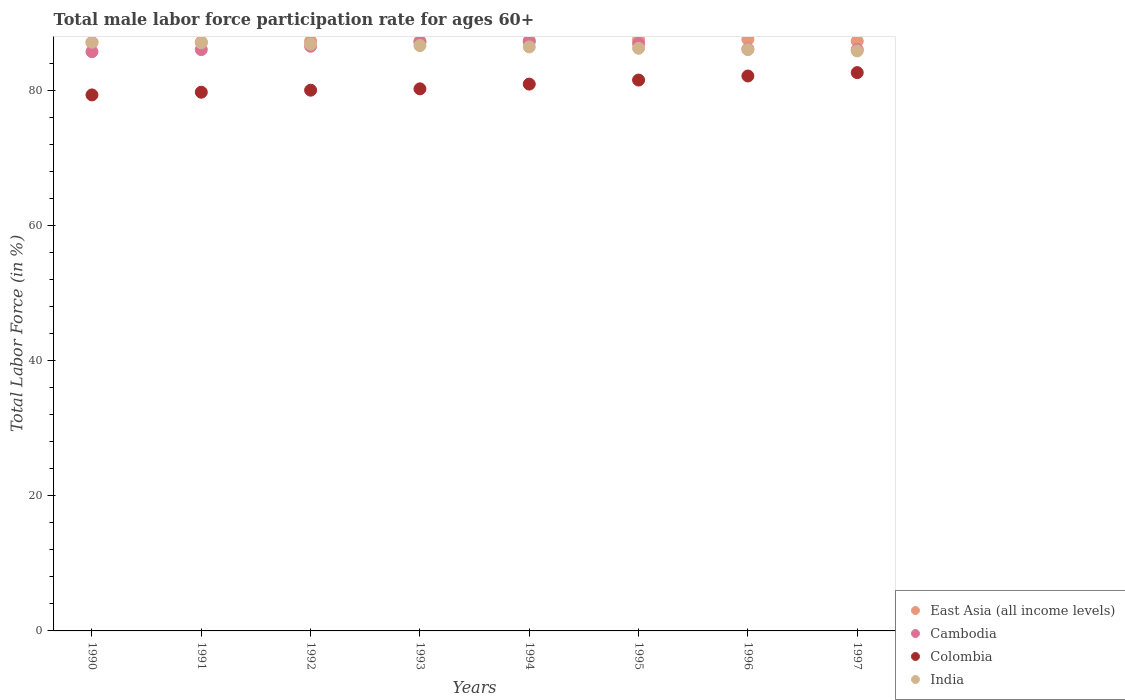How many different coloured dotlines are there?
Keep it short and to the point. 4. Is the number of dotlines equal to the number of legend labels?
Offer a very short reply. Yes. What is the male labor force participation rate in India in 1990?
Provide a short and direct response. 87.1. Across all years, what is the maximum male labor force participation rate in Cambodia?
Make the answer very short. 87.2. Across all years, what is the minimum male labor force participation rate in Cambodia?
Keep it short and to the point. 85.7. What is the total male labor force participation rate in Colombia in the graph?
Your answer should be compact. 646.3. What is the difference between the male labor force participation rate in India in 1990 and that in 1997?
Ensure brevity in your answer.  1.3. What is the difference between the male labor force participation rate in Colombia in 1991 and the male labor force participation rate in Cambodia in 1995?
Offer a very short reply. -7.2. What is the average male labor force participation rate in India per year?
Provide a succinct answer. 86.49. In the year 1992, what is the difference between the male labor force participation rate in East Asia (all income levels) and male labor force participation rate in India?
Your answer should be compact. 0.44. What is the ratio of the male labor force participation rate in Colombia in 1992 to that in 1997?
Keep it short and to the point. 0.97. What is the difference between the highest and the second highest male labor force participation rate in Cambodia?
Offer a terse response. 0.1. What is the difference between the highest and the lowest male labor force participation rate in East Asia (all income levels)?
Your response must be concise. 0.46. Is it the case that in every year, the sum of the male labor force participation rate in India and male labor force participation rate in East Asia (all income levels)  is greater than the sum of male labor force participation rate in Colombia and male labor force participation rate in Cambodia?
Keep it short and to the point. No. Is the male labor force participation rate in East Asia (all income levels) strictly greater than the male labor force participation rate in India over the years?
Your answer should be compact. No. What is the difference between two consecutive major ticks on the Y-axis?
Make the answer very short. 20. Are the values on the major ticks of Y-axis written in scientific E-notation?
Offer a very short reply. No. Does the graph contain any zero values?
Offer a terse response. No. Where does the legend appear in the graph?
Your response must be concise. Bottom right. How many legend labels are there?
Offer a very short reply. 4. What is the title of the graph?
Your answer should be very brief. Total male labor force participation rate for ages 60+. What is the label or title of the X-axis?
Give a very brief answer. Years. What is the Total Labor Force (in %) of East Asia (all income levels) in 1990?
Your answer should be compact. 87.06. What is the Total Labor Force (in %) in Cambodia in 1990?
Provide a short and direct response. 85.7. What is the Total Labor Force (in %) of Colombia in 1990?
Your answer should be very brief. 79.3. What is the Total Labor Force (in %) of India in 1990?
Your answer should be compact. 87.1. What is the Total Labor Force (in %) of East Asia (all income levels) in 1991?
Keep it short and to the point. 87.12. What is the Total Labor Force (in %) in Colombia in 1991?
Your answer should be compact. 79.7. What is the Total Labor Force (in %) of India in 1991?
Provide a succinct answer. 87. What is the Total Labor Force (in %) in East Asia (all income levels) in 1992?
Provide a succinct answer. 87.24. What is the Total Labor Force (in %) in Cambodia in 1992?
Your answer should be compact. 86.5. What is the Total Labor Force (in %) in India in 1992?
Offer a very short reply. 86.8. What is the Total Labor Force (in %) of East Asia (all income levels) in 1993?
Provide a succinct answer. 87.27. What is the Total Labor Force (in %) of Cambodia in 1993?
Your answer should be very brief. 87.1. What is the Total Labor Force (in %) of Colombia in 1993?
Your answer should be compact. 80.2. What is the Total Labor Force (in %) in India in 1993?
Offer a terse response. 86.6. What is the Total Labor Force (in %) in East Asia (all income levels) in 1994?
Provide a succinct answer. 87.32. What is the Total Labor Force (in %) of Cambodia in 1994?
Your response must be concise. 87.2. What is the Total Labor Force (in %) of Colombia in 1994?
Ensure brevity in your answer.  80.9. What is the Total Labor Force (in %) of India in 1994?
Keep it short and to the point. 86.4. What is the Total Labor Force (in %) in East Asia (all income levels) in 1995?
Your response must be concise. 87.46. What is the Total Labor Force (in %) of Cambodia in 1995?
Keep it short and to the point. 86.9. What is the Total Labor Force (in %) of Colombia in 1995?
Offer a very short reply. 81.5. What is the Total Labor Force (in %) in India in 1995?
Your answer should be compact. 86.2. What is the Total Labor Force (in %) of East Asia (all income levels) in 1996?
Offer a terse response. 87.52. What is the Total Labor Force (in %) of Cambodia in 1996?
Your answer should be very brief. 86.1. What is the Total Labor Force (in %) in Colombia in 1996?
Offer a terse response. 82.1. What is the Total Labor Force (in %) in East Asia (all income levels) in 1997?
Your response must be concise. 87.25. What is the Total Labor Force (in %) of Cambodia in 1997?
Your answer should be compact. 86. What is the Total Labor Force (in %) of Colombia in 1997?
Keep it short and to the point. 82.6. What is the Total Labor Force (in %) in India in 1997?
Provide a short and direct response. 85.8. Across all years, what is the maximum Total Labor Force (in %) in East Asia (all income levels)?
Provide a short and direct response. 87.52. Across all years, what is the maximum Total Labor Force (in %) of Cambodia?
Offer a terse response. 87.2. Across all years, what is the maximum Total Labor Force (in %) of Colombia?
Keep it short and to the point. 82.6. Across all years, what is the maximum Total Labor Force (in %) in India?
Keep it short and to the point. 87.1. Across all years, what is the minimum Total Labor Force (in %) in East Asia (all income levels)?
Ensure brevity in your answer.  87.06. Across all years, what is the minimum Total Labor Force (in %) of Cambodia?
Keep it short and to the point. 85.7. Across all years, what is the minimum Total Labor Force (in %) in Colombia?
Ensure brevity in your answer.  79.3. Across all years, what is the minimum Total Labor Force (in %) of India?
Your answer should be compact. 85.8. What is the total Total Labor Force (in %) of East Asia (all income levels) in the graph?
Keep it short and to the point. 698.25. What is the total Total Labor Force (in %) in Cambodia in the graph?
Provide a short and direct response. 691.5. What is the total Total Labor Force (in %) of Colombia in the graph?
Provide a succinct answer. 646.3. What is the total Total Labor Force (in %) in India in the graph?
Make the answer very short. 691.9. What is the difference between the Total Labor Force (in %) of East Asia (all income levels) in 1990 and that in 1991?
Offer a very short reply. -0.06. What is the difference between the Total Labor Force (in %) of Cambodia in 1990 and that in 1991?
Your response must be concise. -0.3. What is the difference between the Total Labor Force (in %) of India in 1990 and that in 1991?
Keep it short and to the point. 0.1. What is the difference between the Total Labor Force (in %) of East Asia (all income levels) in 1990 and that in 1992?
Your response must be concise. -0.18. What is the difference between the Total Labor Force (in %) in Cambodia in 1990 and that in 1992?
Your response must be concise. -0.8. What is the difference between the Total Labor Force (in %) in East Asia (all income levels) in 1990 and that in 1993?
Your answer should be compact. -0.21. What is the difference between the Total Labor Force (in %) in Cambodia in 1990 and that in 1993?
Give a very brief answer. -1.4. What is the difference between the Total Labor Force (in %) of East Asia (all income levels) in 1990 and that in 1994?
Provide a succinct answer. -0.26. What is the difference between the Total Labor Force (in %) in Cambodia in 1990 and that in 1994?
Your answer should be compact. -1.5. What is the difference between the Total Labor Force (in %) in India in 1990 and that in 1994?
Offer a very short reply. 0.7. What is the difference between the Total Labor Force (in %) in East Asia (all income levels) in 1990 and that in 1995?
Ensure brevity in your answer.  -0.39. What is the difference between the Total Labor Force (in %) in Cambodia in 1990 and that in 1995?
Provide a short and direct response. -1.2. What is the difference between the Total Labor Force (in %) of East Asia (all income levels) in 1990 and that in 1996?
Your response must be concise. -0.46. What is the difference between the Total Labor Force (in %) of Cambodia in 1990 and that in 1996?
Offer a terse response. -0.4. What is the difference between the Total Labor Force (in %) of Colombia in 1990 and that in 1996?
Make the answer very short. -2.8. What is the difference between the Total Labor Force (in %) of East Asia (all income levels) in 1990 and that in 1997?
Provide a succinct answer. -0.19. What is the difference between the Total Labor Force (in %) of Cambodia in 1990 and that in 1997?
Make the answer very short. -0.3. What is the difference between the Total Labor Force (in %) in Colombia in 1990 and that in 1997?
Give a very brief answer. -3.3. What is the difference between the Total Labor Force (in %) in India in 1990 and that in 1997?
Provide a succinct answer. 1.3. What is the difference between the Total Labor Force (in %) of East Asia (all income levels) in 1991 and that in 1992?
Your answer should be compact. -0.12. What is the difference between the Total Labor Force (in %) of Cambodia in 1991 and that in 1992?
Offer a terse response. -0.5. What is the difference between the Total Labor Force (in %) in Colombia in 1991 and that in 1992?
Your response must be concise. -0.3. What is the difference between the Total Labor Force (in %) in East Asia (all income levels) in 1991 and that in 1993?
Provide a short and direct response. -0.15. What is the difference between the Total Labor Force (in %) of Cambodia in 1991 and that in 1993?
Your answer should be compact. -1.1. What is the difference between the Total Labor Force (in %) in India in 1991 and that in 1993?
Your response must be concise. 0.4. What is the difference between the Total Labor Force (in %) of East Asia (all income levels) in 1991 and that in 1994?
Ensure brevity in your answer.  -0.2. What is the difference between the Total Labor Force (in %) in Cambodia in 1991 and that in 1994?
Offer a terse response. -1.2. What is the difference between the Total Labor Force (in %) of Colombia in 1991 and that in 1994?
Your answer should be very brief. -1.2. What is the difference between the Total Labor Force (in %) of India in 1991 and that in 1994?
Make the answer very short. 0.6. What is the difference between the Total Labor Force (in %) in East Asia (all income levels) in 1991 and that in 1995?
Keep it short and to the point. -0.33. What is the difference between the Total Labor Force (in %) of Cambodia in 1991 and that in 1995?
Ensure brevity in your answer.  -0.9. What is the difference between the Total Labor Force (in %) of India in 1991 and that in 1995?
Offer a terse response. 0.8. What is the difference between the Total Labor Force (in %) of East Asia (all income levels) in 1991 and that in 1996?
Provide a succinct answer. -0.4. What is the difference between the Total Labor Force (in %) in Colombia in 1991 and that in 1996?
Provide a short and direct response. -2.4. What is the difference between the Total Labor Force (in %) in East Asia (all income levels) in 1991 and that in 1997?
Ensure brevity in your answer.  -0.13. What is the difference between the Total Labor Force (in %) in East Asia (all income levels) in 1992 and that in 1993?
Your response must be concise. -0.03. What is the difference between the Total Labor Force (in %) in Colombia in 1992 and that in 1993?
Offer a very short reply. -0.2. What is the difference between the Total Labor Force (in %) of East Asia (all income levels) in 1992 and that in 1994?
Make the answer very short. -0.08. What is the difference between the Total Labor Force (in %) of Colombia in 1992 and that in 1994?
Your answer should be very brief. -0.9. What is the difference between the Total Labor Force (in %) in India in 1992 and that in 1994?
Your answer should be compact. 0.4. What is the difference between the Total Labor Force (in %) of East Asia (all income levels) in 1992 and that in 1995?
Your answer should be very brief. -0.21. What is the difference between the Total Labor Force (in %) of Cambodia in 1992 and that in 1995?
Your response must be concise. -0.4. What is the difference between the Total Labor Force (in %) of Colombia in 1992 and that in 1995?
Your answer should be compact. -1.5. What is the difference between the Total Labor Force (in %) of India in 1992 and that in 1995?
Make the answer very short. 0.6. What is the difference between the Total Labor Force (in %) of East Asia (all income levels) in 1992 and that in 1996?
Provide a succinct answer. -0.28. What is the difference between the Total Labor Force (in %) in Cambodia in 1992 and that in 1996?
Your response must be concise. 0.4. What is the difference between the Total Labor Force (in %) of Colombia in 1992 and that in 1996?
Your answer should be compact. -2.1. What is the difference between the Total Labor Force (in %) of East Asia (all income levels) in 1992 and that in 1997?
Your answer should be compact. -0.01. What is the difference between the Total Labor Force (in %) of Colombia in 1992 and that in 1997?
Provide a short and direct response. -2.6. What is the difference between the Total Labor Force (in %) of East Asia (all income levels) in 1993 and that in 1994?
Your answer should be compact. -0.05. What is the difference between the Total Labor Force (in %) in Cambodia in 1993 and that in 1994?
Keep it short and to the point. -0.1. What is the difference between the Total Labor Force (in %) of India in 1993 and that in 1994?
Provide a succinct answer. 0.2. What is the difference between the Total Labor Force (in %) in East Asia (all income levels) in 1993 and that in 1995?
Offer a terse response. -0.18. What is the difference between the Total Labor Force (in %) in Cambodia in 1993 and that in 1995?
Offer a terse response. 0.2. What is the difference between the Total Labor Force (in %) of Colombia in 1993 and that in 1995?
Your response must be concise. -1.3. What is the difference between the Total Labor Force (in %) of East Asia (all income levels) in 1993 and that in 1996?
Offer a terse response. -0.25. What is the difference between the Total Labor Force (in %) of Cambodia in 1993 and that in 1996?
Keep it short and to the point. 1. What is the difference between the Total Labor Force (in %) of Colombia in 1993 and that in 1996?
Offer a terse response. -1.9. What is the difference between the Total Labor Force (in %) of India in 1993 and that in 1996?
Make the answer very short. 0.6. What is the difference between the Total Labor Force (in %) in East Asia (all income levels) in 1993 and that in 1997?
Your answer should be very brief. 0.02. What is the difference between the Total Labor Force (in %) in Cambodia in 1993 and that in 1997?
Your response must be concise. 1.1. What is the difference between the Total Labor Force (in %) in Colombia in 1993 and that in 1997?
Provide a short and direct response. -2.4. What is the difference between the Total Labor Force (in %) of India in 1993 and that in 1997?
Your answer should be very brief. 0.8. What is the difference between the Total Labor Force (in %) of East Asia (all income levels) in 1994 and that in 1995?
Ensure brevity in your answer.  -0.13. What is the difference between the Total Labor Force (in %) in Cambodia in 1994 and that in 1995?
Keep it short and to the point. 0.3. What is the difference between the Total Labor Force (in %) in East Asia (all income levels) in 1994 and that in 1996?
Keep it short and to the point. -0.2. What is the difference between the Total Labor Force (in %) of Cambodia in 1994 and that in 1996?
Ensure brevity in your answer.  1.1. What is the difference between the Total Labor Force (in %) of East Asia (all income levels) in 1994 and that in 1997?
Offer a terse response. 0.07. What is the difference between the Total Labor Force (in %) of East Asia (all income levels) in 1995 and that in 1996?
Your answer should be compact. -0.07. What is the difference between the Total Labor Force (in %) of India in 1995 and that in 1996?
Keep it short and to the point. 0.2. What is the difference between the Total Labor Force (in %) in East Asia (all income levels) in 1995 and that in 1997?
Your answer should be compact. 0.2. What is the difference between the Total Labor Force (in %) in Cambodia in 1995 and that in 1997?
Provide a short and direct response. 0.9. What is the difference between the Total Labor Force (in %) in India in 1995 and that in 1997?
Offer a very short reply. 0.4. What is the difference between the Total Labor Force (in %) of East Asia (all income levels) in 1996 and that in 1997?
Keep it short and to the point. 0.27. What is the difference between the Total Labor Force (in %) in Cambodia in 1996 and that in 1997?
Provide a succinct answer. 0.1. What is the difference between the Total Labor Force (in %) in Colombia in 1996 and that in 1997?
Offer a terse response. -0.5. What is the difference between the Total Labor Force (in %) of India in 1996 and that in 1997?
Your answer should be very brief. 0.2. What is the difference between the Total Labor Force (in %) in East Asia (all income levels) in 1990 and the Total Labor Force (in %) in Cambodia in 1991?
Give a very brief answer. 1.06. What is the difference between the Total Labor Force (in %) in East Asia (all income levels) in 1990 and the Total Labor Force (in %) in Colombia in 1991?
Your response must be concise. 7.36. What is the difference between the Total Labor Force (in %) of East Asia (all income levels) in 1990 and the Total Labor Force (in %) of India in 1991?
Ensure brevity in your answer.  0.06. What is the difference between the Total Labor Force (in %) of Cambodia in 1990 and the Total Labor Force (in %) of Colombia in 1991?
Your answer should be very brief. 6. What is the difference between the Total Labor Force (in %) in Colombia in 1990 and the Total Labor Force (in %) in India in 1991?
Your response must be concise. -7.7. What is the difference between the Total Labor Force (in %) in East Asia (all income levels) in 1990 and the Total Labor Force (in %) in Cambodia in 1992?
Provide a short and direct response. 0.56. What is the difference between the Total Labor Force (in %) in East Asia (all income levels) in 1990 and the Total Labor Force (in %) in Colombia in 1992?
Ensure brevity in your answer.  7.06. What is the difference between the Total Labor Force (in %) of East Asia (all income levels) in 1990 and the Total Labor Force (in %) of India in 1992?
Your answer should be compact. 0.26. What is the difference between the Total Labor Force (in %) in Cambodia in 1990 and the Total Labor Force (in %) in Colombia in 1992?
Provide a succinct answer. 5.7. What is the difference between the Total Labor Force (in %) in Colombia in 1990 and the Total Labor Force (in %) in India in 1992?
Ensure brevity in your answer.  -7.5. What is the difference between the Total Labor Force (in %) of East Asia (all income levels) in 1990 and the Total Labor Force (in %) of Cambodia in 1993?
Offer a terse response. -0.04. What is the difference between the Total Labor Force (in %) in East Asia (all income levels) in 1990 and the Total Labor Force (in %) in Colombia in 1993?
Ensure brevity in your answer.  6.86. What is the difference between the Total Labor Force (in %) in East Asia (all income levels) in 1990 and the Total Labor Force (in %) in India in 1993?
Your response must be concise. 0.46. What is the difference between the Total Labor Force (in %) of Cambodia in 1990 and the Total Labor Force (in %) of Colombia in 1993?
Provide a short and direct response. 5.5. What is the difference between the Total Labor Force (in %) in Colombia in 1990 and the Total Labor Force (in %) in India in 1993?
Provide a short and direct response. -7.3. What is the difference between the Total Labor Force (in %) in East Asia (all income levels) in 1990 and the Total Labor Force (in %) in Cambodia in 1994?
Keep it short and to the point. -0.14. What is the difference between the Total Labor Force (in %) of East Asia (all income levels) in 1990 and the Total Labor Force (in %) of Colombia in 1994?
Your response must be concise. 6.16. What is the difference between the Total Labor Force (in %) of East Asia (all income levels) in 1990 and the Total Labor Force (in %) of India in 1994?
Offer a terse response. 0.66. What is the difference between the Total Labor Force (in %) of Cambodia in 1990 and the Total Labor Force (in %) of Colombia in 1994?
Provide a succinct answer. 4.8. What is the difference between the Total Labor Force (in %) of Cambodia in 1990 and the Total Labor Force (in %) of India in 1994?
Offer a very short reply. -0.7. What is the difference between the Total Labor Force (in %) of East Asia (all income levels) in 1990 and the Total Labor Force (in %) of Cambodia in 1995?
Offer a terse response. 0.16. What is the difference between the Total Labor Force (in %) of East Asia (all income levels) in 1990 and the Total Labor Force (in %) of Colombia in 1995?
Provide a succinct answer. 5.56. What is the difference between the Total Labor Force (in %) of East Asia (all income levels) in 1990 and the Total Labor Force (in %) of India in 1995?
Offer a very short reply. 0.86. What is the difference between the Total Labor Force (in %) of Cambodia in 1990 and the Total Labor Force (in %) of Colombia in 1995?
Keep it short and to the point. 4.2. What is the difference between the Total Labor Force (in %) of Cambodia in 1990 and the Total Labor Force (in %) of India in 1995?
Offer a very short reply. -0.5. What is the difference between the Total Labor Force (in %) of East Asia (all income levels) in 1990 and the Total Labor Force (in %) of Cambodia in 1996?
Make the answer very short. 0.96. What is the difference between the Total Labor Force (in %) of East Asia (all income levels) in 1990 and the Total Labor Force (in %) of Colombia in 1996?
Offer a very short reply. 4.96. What is the difference between the Total Labor Force (in %) in East Asia (all income levels) in 1990 and the Total Labor Force (in %) in India in 1996?
Offer a terse response. 1.06. What is the difference between the Total Labor Force (in %) in East Asia (all income levels) in 1990 and the Total Labor Force (in %) in Cambodia in 1997?
Offer a very short reply. 1.06. What is the difference between the Total Labor Force (in %) of East Asia (all income levels) in 1990 and the Total Labor Force (in %) of Colombia in 1997?
Ensure brevity in your answer.  4.46. What is the difference between the Total Labor Force (in %) in East Asia (all income levels) in 1990 and the Total Labor Force (in %) in India in 1997?
Provide a short and direct response. 1.26. What is the difference between the Total Labor Force (in %) in Cambodia in 1990 and the Total Labor Force (in %) in India in 1997?
Your answer should be very brief. -0.1. What is the difference between the Total Labor Force (in %) in East Asia (all income levels) in 1991 and the Total Labor Force (in %) in Cambodia in 1992?
Keep it short and to the point. 0.62. What is the difference between the Total Labor Force (in %) of East Asia (all income levels) in 1991 and the Total Labor Force (in %) of Colombia in 1992?
Your response must be concise. 7.12. What is the difference between the Total Labor Force (in %) of East Asia (all income levels) in 1991 and the Total Labor Force (in %) of India in 1992?
Keep it short and to the point. 0.32. What is the difference between the Total Labor Force (in %) of Cambodia in 1991 and the Total Labor Force (in %) of India in 1992?
Your answer should be compact. -0.8. What is the difference between the Total Labor Force (in %) of Colombia in 1991 and the Total Labor Force (in %) of India in 1992?
Ensure brevity in your answer.  -7.1. What is the difference between the Total Labor Force (in %) in East Asia (all income levels) in 1991 and the Total Labor Force (in %) in Cambodia in 1993?
Your answer should be very brief. 0.02. What is the difference between the Total Labor Force (in %) in East Asia (all income levels) in 1991 and the Total Labor Force (in %) in Colombia in 1993?
Give a very brief answer. 6.92. What is the difference between the Total Labor Force (in %) in East Asia (all income levels) in 1991 and the Total Labor Force (in %) in India in 1993?
Give a very brief answer. 0.52. What is the difference between the Total Labor Force (in %) in Cambodia in 1991 and the Total Labor Force (in %) in India in 1993?
Offer a terse response. -0.6. What is the difference between the Total Labor Force (in %) of East Asia (all income levels) in 1991 and the Total Labor Force (in %) of Cambodia in 1994?
Your answer should be very brief. -0.08. What is the difference between the Total Labor Force (in %) of East Asia (all income levels) in 1991 and the Total Labor Force (in %) of Colombia in 1994?
Ensure brevity in your answer.  6.22. What is the difference between the Total Labor Force (in %) of East Asia (all income levels) in 1991 and the Total Labor Force (in %) of India in 1994?
Your answer should be compact. 0.72. What is the difference between the Total Labor Force (in %) of Cambodia in 1991 and the Total Labor Force (in %) of India in 1994?
Make the answer very short. -0.4. What is the difference between the Total Labor Force (in %) of East Asia (all income levels) in 1991 and the Total Labor Force (in %) of Cambodia in 1995?
Provide a succinct answer. 0.22. What is the difference between the Total Labor Force (in %) in East Asia (all income levels) in 1991 and the Total Labor Force (in %) in Colombia in 1995?
Your answer should be compact. 5.62. What is the difference between the Total Labor Force (in %) in East Asia (all income levels) in 1991 and the Total Labor Force (in %) in India in 1995?
Provide a succinct answer. 0.92. What is the difference between the Total Labor Force (in %) in Cambodia in 1991 and the Total Labor Force (in %) in Colombia in 1995?
Give a very brief answer. 4.5. What is the difference between the Total Labor Force (in %) in Colombia in 1991 and the Total Labor Force (in %) in India in 1995?
Provide a short and direct response. -6.5. What is the difference between the Total Labor Force (in %) of East Asia (all income levels) in 1991 and the Total Labor Force (in %) of Cambodia in 1996?
Provide a succinct answer. 1.02. What is the difference between the Total Labor Force (in %) of East Asia (all income levels) in 1991 and the Total Labor Force (in %) of Colombia in 1996?
Offer a very short reply. 5.02. What is the difference between the Total Labor Force (in %) of East Asia (all income levels) in 1991 and the Total Labor Force (in %) of India in 1996?
Provide a succinct answer. 1.12. What is the difference between the Total Labor Force (in %) of Cambodia in 1991 and the Total Labor Force (in %) of India in 1996?
Offer a terse response. 0. What is the difference between the Total Labor Force (in %) in East Asia (all income levels) in 1991 and the Total Labor Force (in %) in Cambodia in 1997?
Your answer should be very brief. 1.12. What is the difference between the Total Labor Force (in %) in East Asia (all income levels) in 1991 and the Total Labor Force (in %) in Colombia in 1997?
Give a very brief answer. 4.52. What is the difference between the Total Labor Force (in %) in East Asia (all income levels) in 1991 and the Total Labor Force (in %) in India in 1997?
Keep it short and to the point. 1.32. What is the difference between the Total Labor Force (in %) of East Asia (all income levels) in 1992 and the Total Labor Force (in %) of Cambodia in 1993?
Your response must be concise. 0.14. What is the difference between the Total Labor Force (in %) in East Asia (all income levels) in 1992 and the Total Labor Force (in %) in Colombia in 1993?
Provide a short and direct response. 7.04. What is the difference between the Total Labor Force (in %) in East Asia (all income levels) in 1992 and the Total Labor Force (in %) in India in 1993?
Keep it short and to the point. 0.64. What is the difference between the Total Labor Force (in %) of Cambodia in 1992 and the Total Labor Force (in %) of Colombia in 1993?
Keep it short and to the point. 6.3. What is the difference between the Total Labor Force (in %) in Cambodia in 1992 and the Total Labor Force (in %) in India in 1993?
Offer a terse response. -0.1. What is the difference between the Total Labor Force (in %) of East Asia (all income levels) in 1992 and the Total Labor Force (in %) of Cambodia in 1994?
Your answer should be very brief. 0.04. What is the difference between the Total Labor Force (in %) of East Asia (all income levels) in 1992 and the Total Labor Force (in %) of Colombia in 1994?
Give a very brief answer. 6.34. What is the difference between the Total Labor Force (in %) of East Asia (all income levels) in 1992 and the Total Labor Force (in %) of India in 1994?
Offer a very short reply. 0.84. What is the difference between the Total Labor Force (in %) of Cambodia in 1992 and the Total Labor Force (in %) of Colombia in 1994?
Offer a very short reply. 5.6. What is the difference between the Total Labor Force (in %) of Cambodia in 1992 and the Total Labor Force (in %) of India in 1994?
Give a very brief answer. 0.1. What is the difference between the Total Labor Force (in %) in Colombia in 1992 and the Total Labor Force (in %) in India in 1994?
Give a very brief answer. -6.4. What is the difference between the Total Labor Force (in %) of East Asia (all income levels) in 1992 and the Total Labor Force (in %) of Cambodia in 1995?
Provide a succinct answer. 0.34. What is the difference between the Total Labor Force (in %) of East Asia (all income levels) in 1992 and the Total Labor Force (in %) of Colombia in 1995?
Offer a terse response. 5.74. What is the difference between the Total Labor Force (in %) in East Asia (all income levels) in 1992 and the Total Labor Force (in %) in India in 1995?
Offer a very short reply. 1.04. What is the difference between the Total Labor Force (in %) of East Asia (all income levels) in 1992 and the Total Labor Force (in %) of Cambodia in 1996?
Ensure brevity in your answer.  1.14. What is the difference between the Total Labor Force (in %) in East Asia (all income levels) in 1992 and the Total Labor Force (in %) in Colombia in 1996?
Offer a terse response. 5.14. What is the difference between the Total Labor Force (in %) in East Asia (all income levels) in 1992 and the Total Labor Force (in %) in India in 1996?
Keep it short and to the point. 1.24. What is the difference between the Total Labor Force (in %) of Cambodia in 1992 and the Total Labor Force (in %) of Colombia in 1996?
Your response must be concise. 4.4. What is the difference between the Total Labor Force (in %) in Colombia in 1992 and the Total Labor Force (in %) in India in 1996?
Ensure brevity in your answer.  -6. What is the difference between the Total Labor Force (in %) of East Asia (all income levels) in 1992 and the Total Labor Force (in %) of Cambodia in 1997?
Offer a very short reply. 1.24. What is the difference between the Total Labor Force (in %) of East Asia (all income levels) in 1992 and the Total Labor Force (in %) of Colombia in 1997?
Provide a short and direct response. 4.64. What is the difference between the Total Labor Force (in %) of East Asia (all income levels) in 1992 and the Total Labor Force (in %) of India in 1997?
Keep it short and to the point. 1.44. What is the difference between the Total Labor Force (in %) of Cambodia in 1992 and the Total Labor Force (in %) of India in 1997?
Provide a short and direct response. 0.7. What is the difference between the Total Labor Force (in %) of East Asia (all income levels) in 1993 and the Total Labor Force (in %) of Cambodia in 1994?
Make the answer very short. 0.07. What is the difference between the Total Labor Force (in %) of East Asia (all income levels) in 1993 and the Total Labor Force (in %) of Colombia in 1994?
Your response must be concise. 6.37. What is the difference between the Total Labor Force (in %) of East Asia (all income levels) in 1993 and the Total Labor Force (in %) of India in 1994?
Offer a very short reply. 0.87. What is the difference between the Total Labor Force (in %) of Cambodia in 1993 and the Total Labor Force (in %) of India in 1994?
Offer a very short reply. 0.7. What is the difference between the Total Labor Force (in %) of Colombia in 1993 and the Total Labor Force (in %) of India in 1994?
Make the answer very short. -6.2. What is the difference between the Total Labor Force (in %) of East Asia (all income levels) in 1993 and the Total Labor Force (in %) of Cambodia in 1995?
Your answer should be very brief. 0.37. What is the difference between the Total Labor Force (in %) in East Asia (all income levels) in 1993 and the Total Labor Force (in %) in Colombia in 1995?
Your response must be concise. 5.77. What is the difference between the Total Labor Force (in %) of East Asia (all income levels) in 1993 and the Total Labor Force (in %) of India in 1995?
Offer a terse response. 1.07. What is the difference between the Total Labor Force (in %) of Cambodia in 1993 and the Total Labor Force (in %) of Colombia in 1995?
Your answer should be very brief. 5.6. What is the difference between the Total Labor Force (in %) of East Asia (all income levels) in 1993 and the Total Labor Force (in %) of Cambodia in 1996?
Ensure brevity in your answer.  1.17. What is the difference between the Total Labor Force (in %) of East Asia (all income levels) in 1993 and the Total Labor Force (in %) of Colombia in 1996?
Offer a terse response. 5.17. What is the difference between the Total Labor Force (in %) of East Asia (all income levels) in 1993 and the Total Labor Force (in %) of India in 1996?
Provide a succinct answer. 1.27. What is the difference between the Total Labor Force (in %) in Cambodia in 1993 and the Total Labor Force (in %) in Colombia in 1996?
Give a very brief answer. 5. What is the difference between the Total Labor Force (in %) of Cambodia in 1993 and the Total Labor Force (in %) of India in 1996?
Your response must be concise. 1.1. What is the difference between the Total Labor Force (in %) in East Asia (all income levels) in 1993 and the Total Labor Force (in %) in Cambodia in 1997?
Your answer should be compact. 1.27. What is the difference between the Total Labor Force (in %) in East Asia (all income levels) in 1993 and the Total Labor Force (in %) in Colombia in 1997?
Your response must be concise. 4.67. What is the difference between the Total Labor Force (in %) in East Asia (all income levels) in 1993 and the Total Labor Force (in %) in India in 1997?
Offer a very short reply. 1.47. What is the difference between the Total Labor Force (in %) of Cambodia in 1993 and the Total Labor Force (in %) of India in 1997?
Your answer should be very brief. 1.3. What is the difference between the Total Labor Force (in %) of Colombia in 1993 and the Total Labor Force (in %) of India in 1997?
Provide a short and direct response. -5.6. What is the difference between the Total Labor Force (in %) in East Asia (all income levels) in 1994 and the Total Labor Force (in %) in Cambodia in 1995?
Ensure brevity in your answer.  0.42. What is the difference between the Total Labor Force (in %) of East Asia (all income levels) in 1994 and the Total Labor Force (in %) of Colombia in 1995?
Your response must be concise. 5.82. What is the difference between the Total Labor Force (in %) in East Asia (all income levels) in 1994 and the Total Labor Force (in %) in India in 1995?
Keep it short and to the point. 1.12. What is the difference between the Total Labor Force (in %) in Cambodia in 1994 and the Total Labor Force (in %) in Colombia in 1995?
Make the answer very short. 5.7. What is the difference between the Total Labor Force (in %) in East Asia (all income levels) in 1994 and the Total Labor Force (in %) in Cambodia in 1996?
Ensure brevity in your answer.  1.22. What is the difference between the Total Labor Force (in %) in East Asia (all income levels) in 1994 and the Total Labor Force (in %) in Colombia in 1996?
Offer a very short reply. 5.22. What is the difference between the Total Labor Force (in %) of East Asia (all income levels) in 1994 and the Total Labor Force (in %) of India in 1996?
Make the answer very short. 1.32. What is the difference between the Total Labor Force (in %) of Cambodia in 1994 and the Total Labor Force (in %) of Colombia in 1996?
Provide a succinct answer. 5.1. What is the difference between the Total Labor Force (in %) of Cambodia in 1994 and the Total Labor Force (in %) of India in 1996?
Offer a terse response. 1.2. What is the difference between the Total Labor Force (in %) in East Asia (all income levels) in 1994 and the Total Labor Force (in %) in Cambodia in 1997?
Give a very brief answer. 1.32. What is the difference between the Total Labor Force (in %) in East Asia (all income levels) in 1994 and the Total Labor Force (in %) in Colombia in 1997?
Make the answer very short. 4.72. What is the difference between the Total Labor Force (in %) of East Asia (all income levels) in 1994 and the Total Labor Force (in %) of India in 1997?
Make the answer very short. 1.52. What is the difference between the Total Labor Force (in %) of Cambodia in 1994 and the Total Labor Force (in %) of India in 1997?
Keep it short and to the point. 1.4. What is the difference between the Total Labor Force (in %) in East Asia (all income levels) in 1995 and the Total Labor Force (in %) in Cambodia in 1996?
Offer a terse response. 1.36. What is the difference between the Total Labor Force (in %) of East Asia (all income levels) in 1995 and the Total Labor Force (in %) of Colombia in 1996?
Provide a short and direct response. 5.36. What is the difference between the Total Labor Force (in %) in East Asia (all income levels) in 1995 and the Total Labor Force (in %) in India in 1996?
Keep it short and to the point. 1.46. What is the difference between the Total Labor Force (in %) in Cambodia in 1995 and the Total Labor Force (in %) in India in 1996?
Your answer should be compact. 0.9. What is the difference between the Total Labor Force (in %) of Colombia in 1995 and the Total Labor Force (in %) of India in 1996?
Your answer should be very brief. -4.5. What is the difference between the Total Labor Force (in %) in East Asia (all income levels) in 1995 and the Total Labor Force (in %) in Cambodia in 1997?
Your answer should be compact. 1.46. What is the difference between the Total Labor Force (in %) of East Asia (all income levels) in 1995 and the Total Labor Force (in %) of Colombia in 1997?
Ensure brevity in your answer.  4.86. What is the difference between the Total Labor Force (in %) of East Asia (all income levels) in 1995 and the Total Labor Force (in %) of India in 1997?
Your answer should be very brief. 1.66. What is the difference between the Total Labor Force (in %) in Cambodia in 1995 and the Total Labor Force (in %) in Colombia in 1997?
Provide a short and direct response. 4.3. What is the difference between the Total Labor Force (in %) of Cambodia in 1995 and the Total Labor Force (in %) of India in 1997?
Your answer should be very brief. 1.1. What is the difference between the Total Labor Force (in %) of East Asia (all income levels) in 1996 and the Total Labor Force (in %) of Cambodia in 1997?
Provide a succinct answer. 1.52. What is the difference between the Total Labor Force (in %) in East Asia (all income levels) in 1996 and the Total Labor Force (in %) in Colombia in 1997?
Make the answer very short. 4.92. What is the difference between the Total Labor Force (in %) in East Asia (all income levels) in 1996 and the Total Labor Force (in %) in India in 1997?
Provide a succinct answer. 1.72. What is the difference between the Total Labor Force (in %) of Cambodia in 1996 and the Total Labor Force (in %) of Colombia in 1997?
Offer a terse response. 3.5. What is the average Total Labor Force (in %) of East Asia (all income levels) per year?
Ensure brevity in your answer.  87.28. What is the average Total Labor Force (in %) in Cambodia per year?
Your response must be concise. 86.44. What is the average Total Labor Force (in %) in Colombia per year?
Provide a succinct answer. 80.79. What is the average Total Labor Force (in %) of India per year?
Give a very brief answer. 86.49. In the year 1990, what is the difference between the Total Labor Force (in %) of East Asia (all income levels) and Total Labor Force (in %) of Cambodia?
Provide a succinct answer. 1.36. In the year 1990, what is the difference between the Total Labor Force (in %) of East Asia (all income levels) and Total Labor Force (in %) of Colombia?
Make the answer very short. 7.76. In the year 1990, what is the difference between the Total Labor Force (in %) in East Asia (all income levels) and Total Labor Force (in %) in India?
Your answer should be very brief. -0.04. In the year 1990, what is the difference between the Total Labor Force (in %) in Cambodia and Total Labor Force (in %) in Colombia?
Give a very brief answer. 6.4. In the year 1991, what is the difference between the Total Labor Force (in %) in East Asia (all income levels) and Total Labor Force (in %) in Cambodia?
Provide a short and direct response. 1.12. In the year 1991, what is the difference between the Total Labor Force (in %) of East Asia (all income levels) and Total Labor Force (in %) of Colombia?
Ensure brevity in your answer.  7.42. In the year 1991, what is the difference between the Total Labor Force (in %) in East Asia (all income levels) and Total Labor Force (in %) in India?
Keep it short and to the point. 0.12. In the year 1991, what is the difference between the Total Labor Force (in %) of Cambodia and Total Labor Force (in %) of India?
Provide a succinct answer. -1. In the year 1991, what is the difference between the Total Labor Force (in %) in Colombia and Total Labor Force (in %) in India?
Ensure brevity in your answer.  -7.3. In the year 1992, what is the difference between the Total Labor Force (in %) of East Asia (all income levels) and Total Labor Force (in %) of Cambodia?
Offer a very short reply. 0.74. In the year 1992, what is the difference between the Total Labor Force (in %) of East Asia (all income levels) and Total Labor Force (in %) of Colombia?
Your response must be concise. 7.24. In the year 1992, what is the difference between the Total Labor Force (in %) in East Asia (all income levels) and Total Labor Force (in %) in India?
Your response must be concise. 0.44. In the year 1993, what is the difference between the Total Labor Force (in %) of East Asia (all income levels) and Total Labor Force (in %) of Cambodia?
Ensure brevity in your answer.  0.17. In the year 1993, what is the difference between the Total Labor Force (in %) in East Asia (all income levels) and Total Labor Force (in %) in Colombia?
Give a very brief answer. 7.07. In the year 1993, what is the difference between the Total Labor Force (in %) of East Asia (all income levels) and Total Labor Force (in %) of India?
Ensure brevity in your answer.  0.67. In the year 1993, what is the difference between the Total Labor Force (in %) of Cambodia and Total Labor Force (in %) of Colombia?
Provide a succinct answer. 6.9. In the year 1994, what is the difference between the Total Labor Force (in %) of East Asia (all income levels) and Total Labor Force (in %) of Cambodia?
Your answer should be very brief. 0.12. In the year 1994, what is the difference between the Total Labor Force (in %) of East Asia (all income levels) and Total Labor Force (in %) of Colombia?
Offer a very short reply. 6.42. In the year 1994, what is the difference between the Total Labor Force (in %) in East Asia (all income levels) and Total Labor Force (in %) in India?
Give a very brief answer. 0.92. In the year 1994, what is the difference between the Total Labor Force (in %) of Colombia and Total Labor Force (in %) of India?
Provide a succinct answer. -5.5. In the year 1995, what is the difference between the Total Labor Force (in %) in East Asia (all income levels) and Total Labor Force (in %) in Cambodia?
Ensure brevity in your answer.  0.56. In the year 1995, what is the difference between the Total Labor Force (in %) in East Asia (all income levels) and Total Labor Force (in %) in Colombia?
Provide a short and direct response. 5.96. In the year 1995, what is the difference between the Total Labor Force (in %) in East Asia (all income levels) and Total Labor Force (in %) in India?
Provide a short and direct response. 1.26. In the year 1995, what is the difference between the Total Labor Force (in %) in Cambodia and Total Labor Force (in %) in India?
Your answer should be compact. 0.7. In the year 1995, what is the difference between the Total Labor Force (in %) of Colombia and Total Labor Force (in %) of India?
Offer a terse response. -4.7. In the year 1996, what is the difference between the Total Labor Force (in %) of East Asia (all income levels) and Total Labor Force (in %) of Cambodia?
Offer a terse response. 1.42. In the year 1996, what is the difference between the Total Labor Force (in %) of East Asia (all income levels) and Total Labor Force (in %) of Colombia?
Provide a short and direct response. 5.42. In the year 1996, what is the difference between the Total Labor Force (in %) of East Asia (all income levels) and Total Labor Force (in %) of India?
Offer a terse response. 1.52. In the year 1996, what is the difference between the Total Labor Force (in %) of Colombia and Total Labor Force (in %) of India?
Keep it short and to the point. -3.9. In the year 1997, what is the difference between the Total Labor Force (in %) of East Asia (all income levels) and Total Labor Force (in %) of Cambodia?
Your answer should be very brief. 1.25. In the year 1997, what is the difference between the Total Labor Force (in %) of East Asia (all income levels) and Total Labor Force (in %) of Colombia?
Your response must be concise. 4.65. In the year 1997, what is the difference between the Total Labor Force (in %) of East Asia (all income levels) and Total Labor Force (in %) of India?
Offer a terse response. 1.45. In the year 1997, what is the difference between the Total Labor Force (in %) in Cambodia and Total Labor Force (in %) in India?
Keep it short and to the point. 0.2. What is the ratio of the Total Labor Force (in %) in Colombia in 1990 to that in 1991?
Offer a terse response. 0.99. What is the ratio of the Total Labor Force (in %) in Colombia in 1990 to that in 1992?
Give a very brief answer. 0.99. What is the ratio of the Total Labor Force (in %) of Cambodia in 1990 to that in 1993?
Ensure brevity in your answer.  0.98. What is the ratio of the Total Labor Force (in %) of Colombia in 1990 to that in 1993?
Ensure brevity in your answer.  0.99. What is the ratio of the Total Labor Force (in %) of India in 1990 to that in 1993?
Your answer should be very brief. 1.01. What is the ratio of the Total Labor Force (in %) in Cambodia in 1990 to that in 1994?
Offer a terse response. 0.98. What is the ratio of the Total Labor Force (in %) of Colombia in 1990 to that in 1994?
Ensure brevity in your answer.  0.98. What is the ratio of the Total Labor Force (in %) in Cambodia in 1990 to that in 1995?
Ensure brevity in your answer.  0.99. What is the ratio of the Total Labor Force (in %) of Colombia in 1990 to that in 1995?
Make the answer very short. 0.97. What is the ratio of the Total Labor Force (in %) in India in 1990 to that in 1995?
Offer a very short reply. 1.01. What is the ratio of the Total Labor Force (in %) in Cambodia in 1990 to that in 1996?
Offer a terse response. 1. What is the ratio of the Total Labor Force (in %) of Colombia in 1990 to that in 1996?
Provide a short and direct response. 0.97. What is the ratio of the Total Labor Force (in %) of India in 1990 to that in 1996?
Provide a succinct answer. 1.01. What is the ratio of the Total Labor Force (in %) in East Asia (all income levels) in 1990 to that in 1997?
Provide a short and direct response. 1. What is the ratio of the Total Labor Force (in %) of India in 1990 to that in 1997?
Give a very brief answer. 1.02. What is the ratio of the Total Labor Force (in %) in East Asia (all income levels) in 1991 to that in 1992?
Offer a terse response. 1. What is the ratio of the Total Labor Force (in %) in Cambodia in 1991 to that in 1992?
Your answer should be compact. 0.99. What is the ratio of the Total Labor Force (in %) in India in 1991 to that in 1992?
Offer a very short reply. 1. What is the ratio of the Total Labor Force (in %) in Cambodia in 1991 to that in 1993?
Keep it short and to the point. 0.99. What is the ratio of the Total Labor Force (in %) in Colombia in 1991 to that in 1993?
Offer a very short reply. 0.99. What is the ratio of the Total Labor Force (in %) of India in 1991 to that in 1993?
Ensure brevity in your answer.  1. What is the ratio of the Total Labor Force (in %) of Cambodia in 1991 to that in 1994?
Your response must be concise. 0.99. What is the ratio of the Total Labor Force (in %) of Colombia in 1991 to that in 1994?
Your response must be concise. 0.99. What is the ratio of the Total Labor Force (in %) in India in 1991 to that in 1994?
Provide a succinct answer. 1.01. What is the ratio of the Total Labor Force (in %) in East Asia (all income levels) in 1991 to that in 1995?
Your response must be concise. 1. What is the ratio of the Total Labor Force (in %) in Colombia in 1991 to that in 1995?
Provide a succinct answer. 0.98. What is the ratio of the Total Labor Force (in %) in India in 1991 to that in 1995?
Your answer should be compact. 1.01. What is the ratio of the Total Labor Force (in %) of Cambodia in 1991 to that in 1996?
Keep it short and to the point. 1. What is the ratio of the Total Labor Force (in %) of Colombia in 1991 to that in 1996?
Keep it short and to the point. 0.97. What is the ratio of the Total Labor Force (in %) in India in 1991 to that in 1996?
Give a very brief answer. 1.01. What is the ratio of the Total Labor Force (in %) of Colombia in 1991 to that in 1997?
Ensure brevity in your answer.  0.96. What is the ratio of the Total Labor Force (in %) in India in 1991 to that in 1997?
Provide a short and direct response. 1.01. What is the ratio of the Total Labor Force (in %) in East Asia (all income levels) in 1992 to that in 1993?
Your response must be concise. 1. What is the ratio of the Total Labor Force (in %) of Cambodia in 1992 to that in 1993?
Your response must be concise. 0.99. What is the ratio of the Total Labor Force (in %) in Cambodia in 1992 to that in 1994?
Keep it short and to the point. 0.99. What is the ratio of the Total Labor Force (in %) in Colombia in 1992 to that in 1994?
Provide a short and direct response. 0.99. What is the ratio of the Total Labor Force (in %) in East Asia (all income levels) in 1992 to that in 1995?
Offer a very short reply. 1. What is the ratio of the Total Labor Force (in %) in Colombia in 1992 to that in 1995?
Give a very brief answer. 0.98. What is the ratio of the Total Labor Force (in %) in Cambodia in 1992 to that in 1996?
Provide a succinct answer. 1. What is the ratio of the Total Labor Force (in %) in Colombia in 1992 to that in 1996?
Provide a succinct answer. 0.97. What is the ratio of the Total Labor Force (in %) in India in 1992 to that in 1996?
Make the answer very short. 1.01. What is the ratio of the Total Labor Force (in %) in East Asia (all income levels) in 1992 to that in 1997?
Offer a very short reply. 1. What is the ratio of the Total Labor Force (in %) of Cambodia in 1992 to that in 1997?
Your answer should be very brief. 1.01. What is the ratio of the Total Labor Force (in %) in Colombia in 1992 to that in 1997?
Your answer should be compact. 0.97. What is the ratio of the Total Labor Force (in %) in India in 1992 to that in 1997?
Provide a succinct answer. 1.01. What is the ratio of the Total Labor Force (in %) in East Asia (all income levels) in 1993 to that in 1994?
Give a very brief answer. 1. What is the ratio of the Total Labor Force (in %) of Cambodia in 1993 to that in 1994?
Provide a short and direct response. 1. What is the ratio of the Total Labor Force (in %) of Cambodia in 1993 to that in 1995?
Your answer should be very brief. 1. What is the ratio of the Total Labor Force (in %) of Colombia in 1993 to that in 1995?
Provide a short and direct response. 0.98. What is the ratio of the Total Labor Force (in %) of East Asia (all income levels) in 1993 to that in 1996?
Provide a succinct answer. 1. What is the ratio of the Total Labor Force (in %) of Cambodia in 1993 to that in 1996?
Offer a very short reply. 1.01. What is the ratio of the Total Labor Force (in %) in Colombia in 1993 to that in 1996?
Your answer should be very brief. 0.98. What is the ratio of the Total Labor Force (in %) of Cambodia in 1993 to that in 1997?
Your answer should be compact. 1.01. What is the ratio of the Total Labor Force (in %) of Colombia in 1993 to that in 1997?
Make the answer very short. 0.97. What is the ratio of the Total Labor Force (in %) in India in 1993 to that in 1997?
Give a very brief answer. 1.01. What is the ratio of the Total Labor Force (in %) in Colombia in 1994 to that in 1995?
Make the answer very short. 0.99. What is the ratio of the Total Labor Force (in %) of East Asia (all income levels) in 1994 to that in 1996?
Keep it short and to the point. 1. What is the ratio of the Total Labor Force (in %) in Cambodia in 1994 to that in 1996?
Give a very brief answer. 1.01. What is the ratio of the Total Labor Force (in %) in Colombia in 1994 to that in 1996?
Give a very brief answer. 0.99. What is the ratio of the Total Labor Force (in %) of India in 1994 to that in 1996?
Provide a succinct answer. 1. What is the ratio of the Total Labor Force (in %) in Colombia in 1994 to that in 1997?
Give a very brief answer. 0.98. What is the ratio of the Total Labor Force (in %) of India in 1994 to that in 1997?
Provide a short and direct response. 1.01. What is the ratio of the Total Labor Force (in %) in Cambodia in 1995 to that in 1996?
Give a very brief answer. 1.01. What is the ratio of the Total Labor Force (in %) in East Asia (all income levels) in 1995 to that in 1997?
Your response must be concise. 1. What is the ratio of the Total Labor Force (in %) of Cambodia in 1995 to that in 1997?
Offer a terse response. 1.01. What is the ratio of the Total Labor Force (in %) of Colombia in 1995 to that in 1997?
Ensure brevity in your answer.  0.99. What is the ratio of the Total Labor Force (in %) of India in 1995 to that in 1997?
Give a very brief answer. 1. What is the ratio of the Total Labor Force (in %) in East Asia (all income levels) in 1996 to that in 1997?
Provide a succinct answer. 1. What is the ratio of the Total Labor Force (in %) in Cambodia in 1996 to that in 1997?
Keep it short and to the point. 1. What is the difference between the highest and the second highest Total Labor Force (in %) of East Asia (all income levels)?
Your answer should be compact. 0.07. What is the difference between the highest and the second highest Total Labor Force (in %) of Colombia?
Offer a terse response. 0.5. What is the difference between the highest and the second highest Total Labor Force (in %) in India?
Ensure brevity in your answer.  0.1. What is the difference between the highest and the lowest Total Labor Force (in %) in East Asia (all income levels)?
Keep it short and to the point. 0.46. What is the difference between the highest and the lowest Total Labor Force (in %) of Cambodia?
Ensure brevity in your answer.  1.5. What is the difference between the highest and the lowest Total Labor Force (in %) of India?
Ensure brevity in your answer.  1.3. 